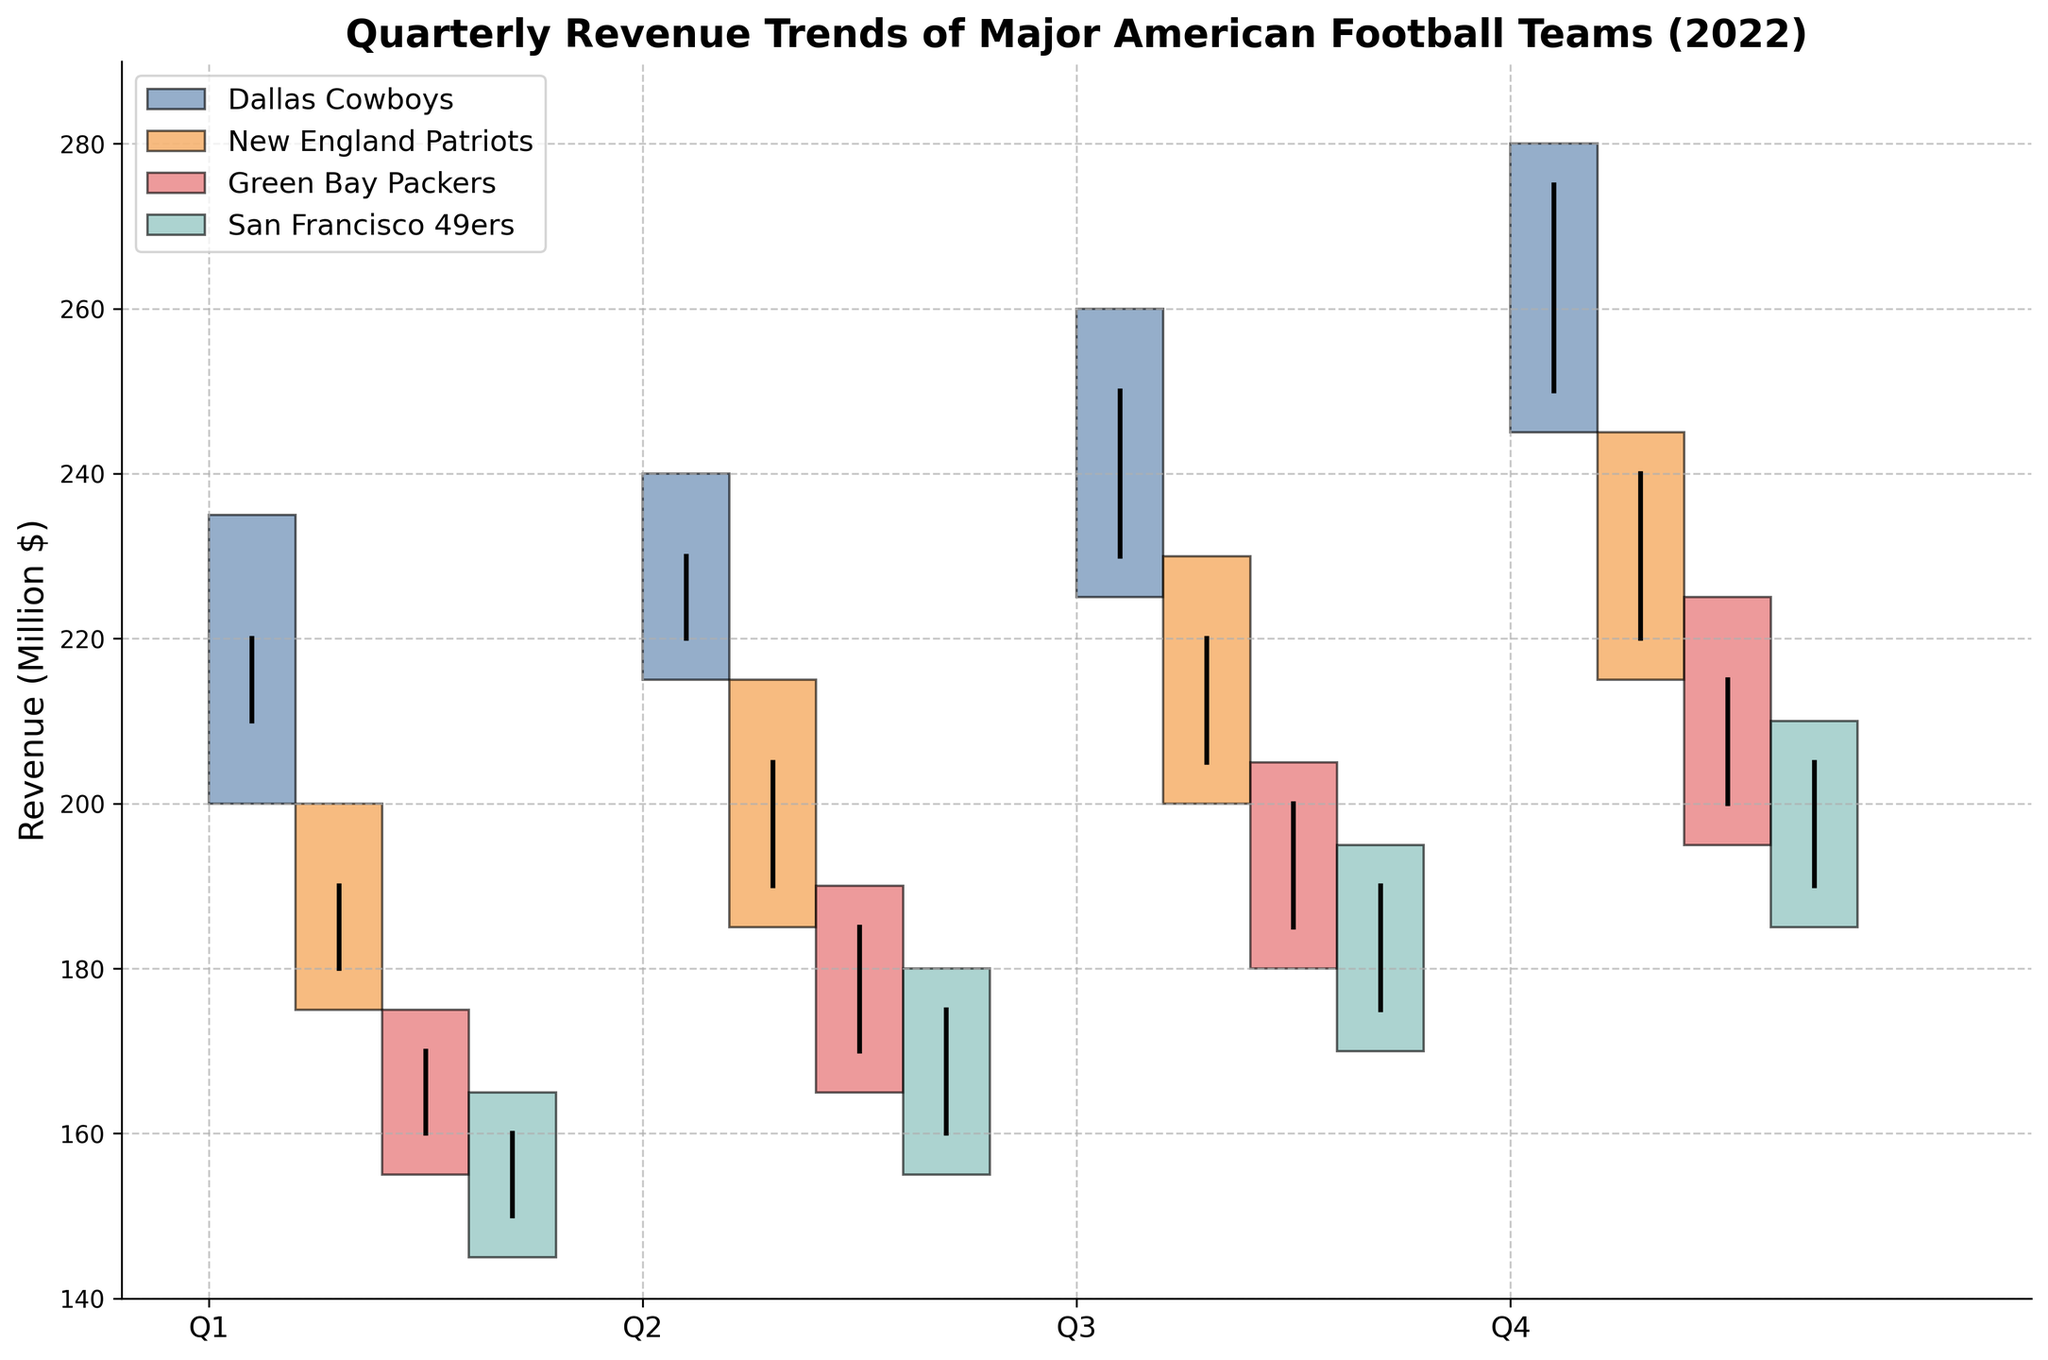What's the revenue range of the Dallas Cowboys in Q3? To find the revenue range, look for the high and low values. In Q3, the high is 260 and the low is 225, so the range is 260 - 225.
Answer: 35 Which team had the highest closing revenue in Q4? Look at the 'Close' values for each team in Q4. The highest closing value among Dallas Cowboys (275), New England Patriots (240), Green Bay Packers (215), and San Francisco 49ers (205) is 275, which belongs to the Dallas Cowboys.
Answer: Dallas Cowboys Did any team have a decreasing trend from Q1 to Q4? To identify a decreasing trend, check if the closing value consistently decreases from Q1 to Q4. For all teams, the closing values increase or remain consistent each quarter.
Answer: No How many different quarters are represented for each team's data? Each team has data for Q1, Q2, Q3, and Q4. There are 4 different quarters for each team.
Answer: 4 What is the average closing revenue across all teams in Q2? The closing revenues in Q2 are: Dallas Cowboys (230), New England Patriots (205), Green Bay Packers (185), San Francisco 49ers (175). Sum these values and divide by 4. (230+205+185+175)/4 = 198.75.
Answer: 198.75 How does the Green Bay Packers' revenue compare from Q1 to Q4? Track the closing values for Q1 (170), Q2 (185), Q3 (200), and Q4 (215). Comparing the quarters: 170 < 185 < 200 < 215 shows a consistently increasing trend.
Answer: Increasing Which team showed the largest increase in closing revenue from Q3 to Q4? Calculate the differences from Q3 to Q4: Dallas Cowboys (275-250=25), New England Patriots (240-220=20), Green Bay Packers (215-200=15), San Francisco 49ers (205-190=15). Dallas Cowboys has the largest increase of 25.
Answer: Dallas Cowboys 